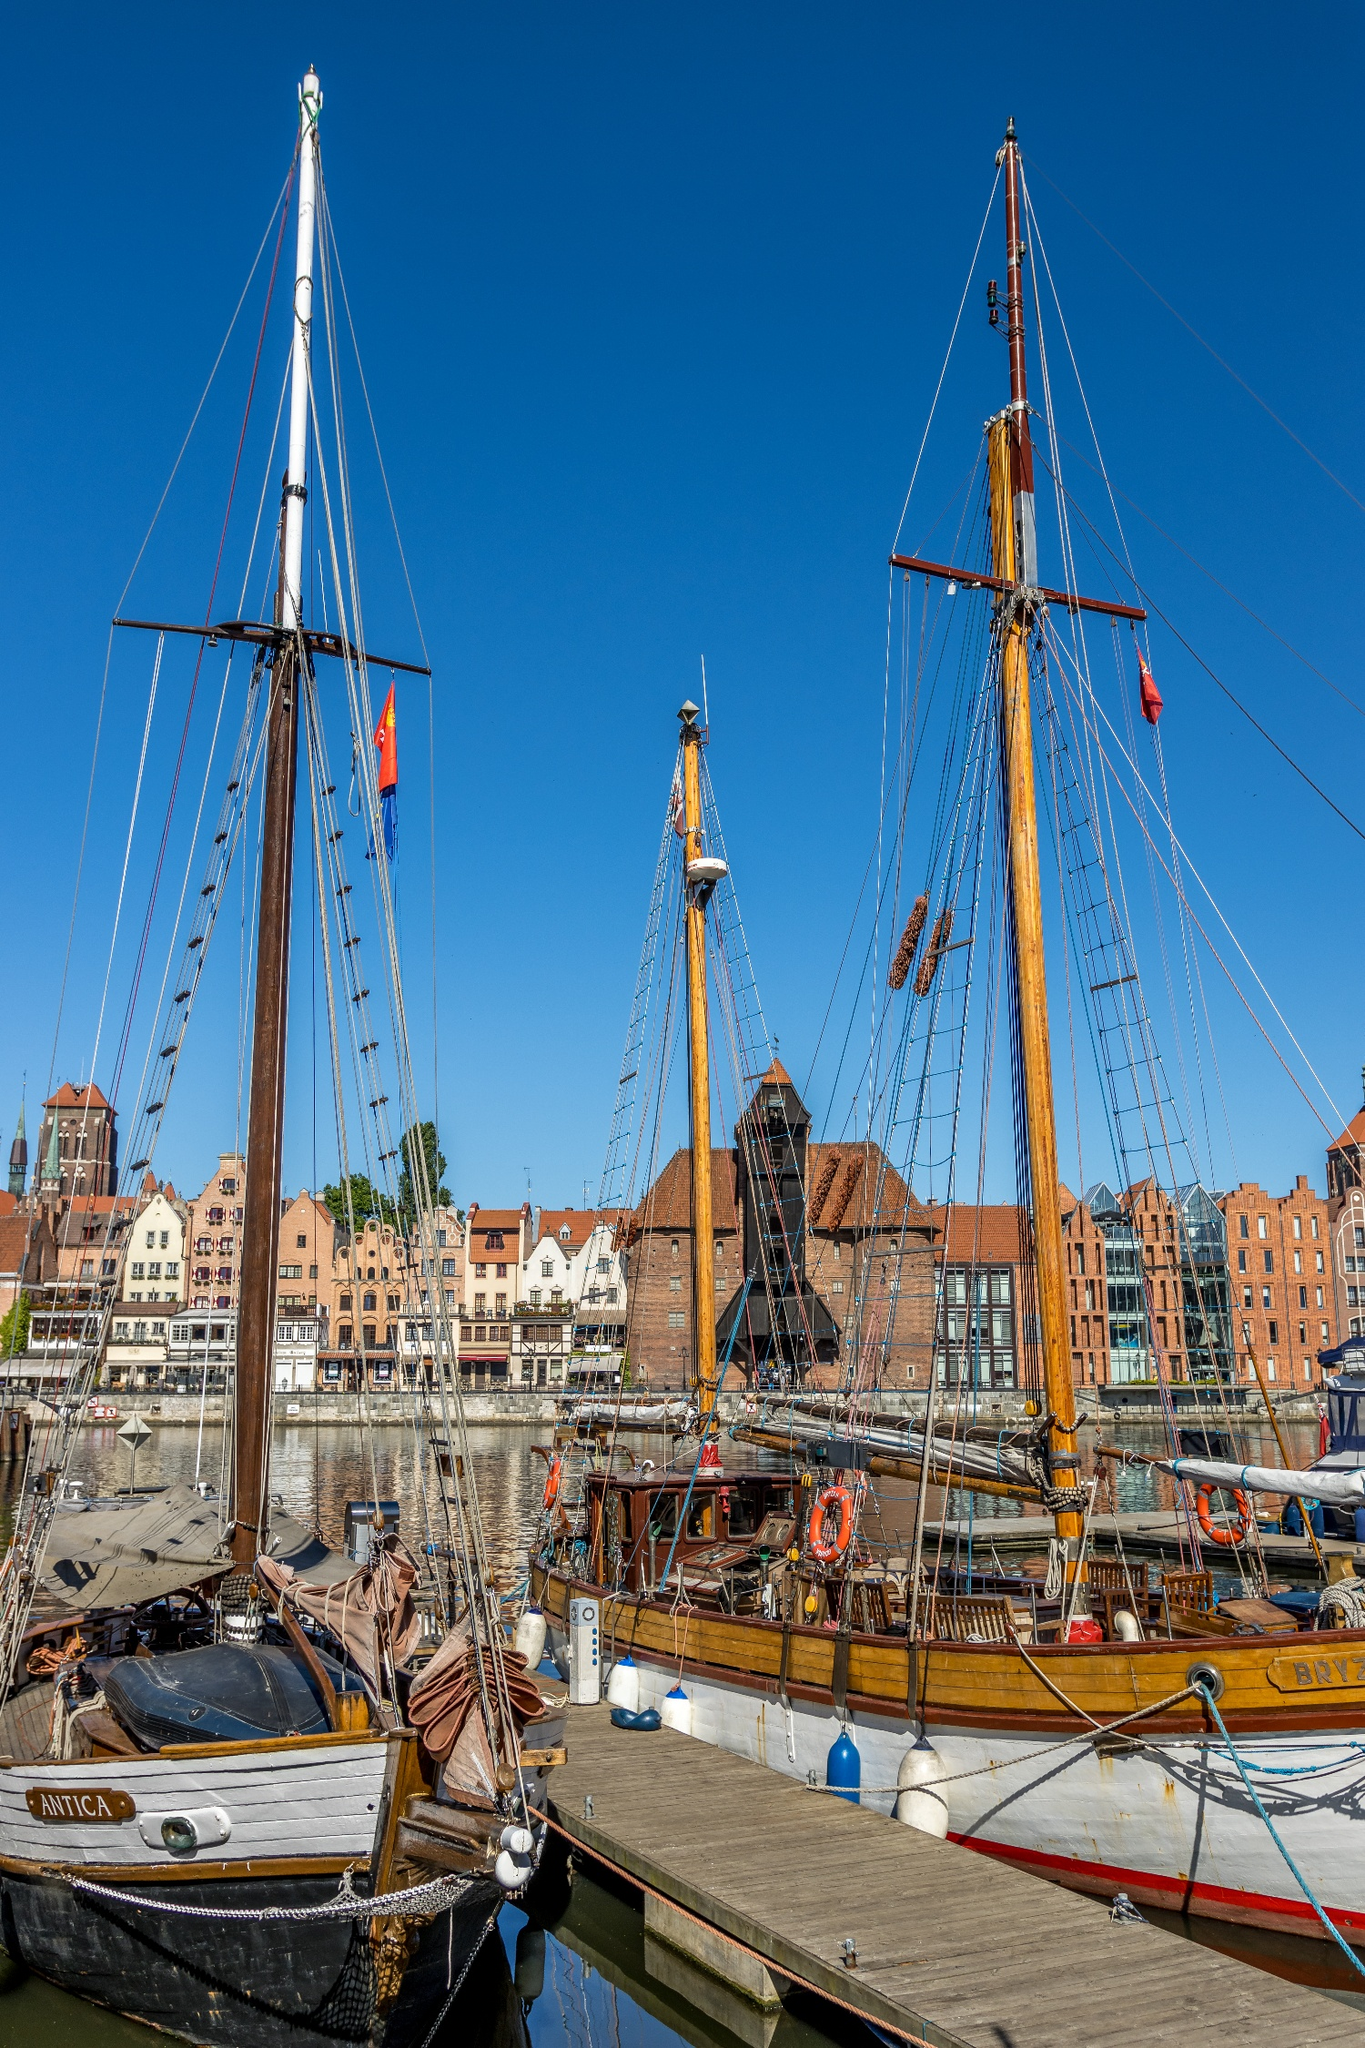Write a detailed description of the given image. The image features a lively scene at the Gdansk harbor in Poland, showcasing an array of classic sailing ships moored at the dock. The dominant ships in the foreground have tall, golden masts and are adorned with numerous flags, signaling a festive or significant day at the harbor. In the background, the cityscape presents a row of distinctive European buildings characterized by their gabled roofs and a varied facade of warm colors ranging from deep orange to light cream. Notable architectural elements like small windows under pointed arches and ornamental ridges enhance the historical feel of the scene. The clear blue sky and calm waters add a serene atmosphere to the bustling harbor, making it a picturesque portrayal of maritime heritage. 